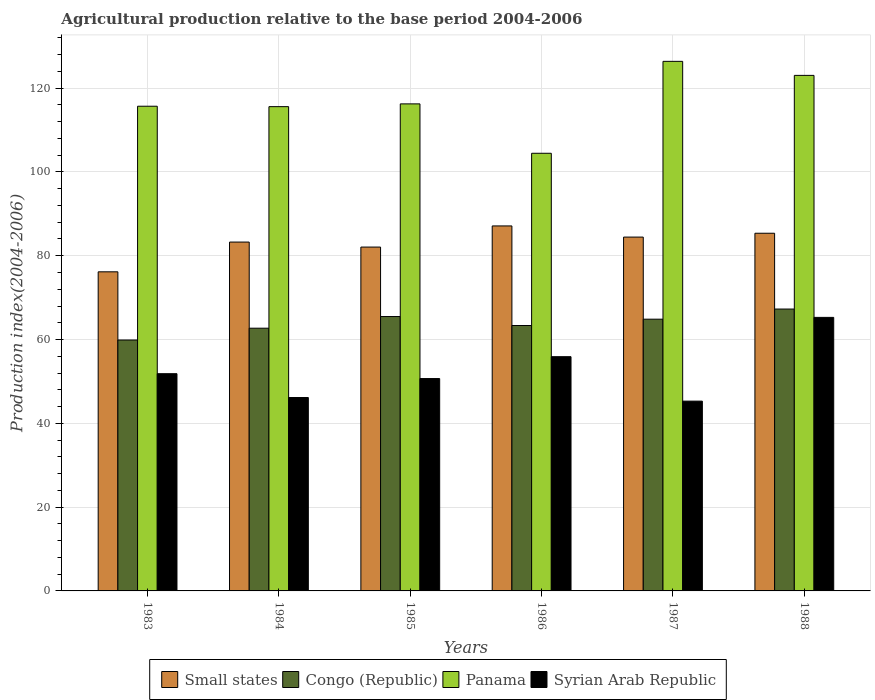How many groups of bars are there?
Ensure brevity in your answer.  6. Are the number of bars per tick equal to the number of legend labels?
Give a very brief answer. Yes. Are the number of bars on each tick of the X-axis equal?
Provide a succinct answer. Yes. How many bars are there on the 6th tick from the left?
Your response must be concise. 4. How many bars are there on the 5th tick from the right?
Offer a terse response. 4. What is the label of the 4th group of bars from the left?
Make the answer very short. 1986. What is the agricultural production index in Syrian Arab Republic in 1983?
Your answer should be compact. 51.85. Across all years, what is the maximum agricultural production index in Syrian Arab Republic?
Your answer should be compact. 65.29. Across all years, what is the minimum agricultural production index in Small states?
Your answer should be very brief. 76.16. In which year was the agricultural production index in Syrian Arab Republic minimum?
Provide a short and direct response. 1987. What is the total agricultural production index in Small states in the graph?
Your answer should be very brief. 498.45. What is the difference between the agricultural production index in Congo (Republic) in 1986 and that in 1987?
Provide a short and direct response. -1.51. What is the difference between the agricultural production index in Panama in 1987 and the agricultural production index in Syrian Arab Republic in 1983?
Offer a terse response. 74.55. What is the average agricultural production index in Congo (Republic) per year?
Provide a short and direct response. 63.93. In the year 1984, what is the difference between the agricultural production index in Small states and agricultural production index in Congo (Republic)?
Your answer should be very brief. 20.56. In how many years, is the agricultural production index in Congo (Republic) greater than 12?
Your answer should be very brief. 6. What is the ratio of the agricultural production index in Syrian Arab Republic in 1983 to that in 1987?
Your answer should be very brief. 1.14. Is the agricultural production index in Small states in 1984 less than that in 1985?
Ensure brevity in your answer.  No. What is the difference between the highest and the second highest agricultural production index in Panama?
Give a very brief answer. 3.35. What is the difference between the highest and the lowest agricultural production index in Small states?
Keep it short and to the point. 10.96. Is it the case that in every year, the sum of the agricultural production index in Syrian Arab Republic and agricultural production index in Congo (Republic) is greater than the sum of agricultural production index in Small states and agricultural production index in Panama?
Ensure brevity in your answer.  No. What does the 2nd bar from the left in 1984 represents?
Give a very brief answer. Congo (Republic). What does the 4th bar from the right in 1984 represents?
Provide a succinct answer. Small states. Is it the case that in every year, the sum of the agricultural production index in Small states and agricultural production index in Panama is greater than the agricultural production index in Syrian Arab Republic?
Your answer should be very brief. Yes. How many bars are there?
Ensure brevity in your answer.  24. Are all the bars in the graph horizontal?
Your response must be concise. No. Are the values on the major ticks of Y-axis written in scientific E-notation?
Give a very brief answer. No. Does the graph contain any zero values?
Give a very brief answer. No. Does the graph contain grids?
Offer a terse response. Yes. Where does the legend appear in the graph?
Give a very brief answer. Bottom center. How are the legend labels stacked?
Your response must be concise. Horizontal. What is the title of the graph?
Provide a short and direct response. Agricultural production relative to the base period 2004-2006. What is the label or title of the Y-axis?
Ensure brevity in your answer.  Production index(2004-2006). What is the Production index(2004-2006) of Small states in 1983?
Keep it short and to the point. 76.16. What is the Production index(2004-2006) of Congo (Republic) in 1983?
Your answer should be compact. 59.89. What is the Production index(2004-2006) in Panama in 1983?
Make the answer very short. 115.69. What is the Production index(2004-2006) of Syrian Arab Republic in 1983?
Your answer should be compact. 51.85. What is the Production index(2004-2006) of Small states in 1984?
Ensure brevity in your answer.  83.27. What is the Production index(2004-2006) in Congo (Republic) in 1984?
Offer a terse response. 62.71. What is the Production index(2004-2006) in Panama in 1984?
Offer a very short reply. 115.59. What is the Production index(2004-2006) of Syrian Arab Republic in 1984?
Your answer should be compact. 46.16. What is the Production index(2004-2006) in Small states in 1985?
Your response must be concise. 82.07. What is the Production index(2004-2006) in Congo (Republic) in 1985?
Offer a very short reply. 65.49. What is the Production index(2004-2006) in Panama in 1985?
Make the answer very short. 116.25. What is the Production index(2004-2006) of Syrian Arab Republic in 1985?
Your answer should be very brief. 50.69. What is the Production index(2004-2006) in Small states in 1986?
Give a very brief answer. 87.12. What is the Production index(2004-2006) of Congo (Republic) in 1986?
Your answer should be compact. 63.35. What is the Production index(2004-2006) of Panama in 1986?
Provide a short and direct response. 104.46. What is the Production index(2004-2006) of Syrian Arab Republic in 1986?
Keep it short and to the point. 55.91. What is the Production index(2004-2006) in Small states in 1987?
Keep it short and to the point. 84.46. What is the Production index(2004-2006) in Congo (Republic) in 1987?
Your answer should be compact. 64.86. What is the Production index(2004-2006) of Panama in 1987?
Your response must be concise. 126.4. What is the Production index(2004-2006) of Syrian Arab Republic in 1987?
Keep it short and to the point. 45.3. What is the Production index(2004-2006) in Small states in 1988?
Give a very brief answer. 85.37. What is the Production index(2004-2006) in Congo (Republic) in 1988?
Provide a short and direct response. 67.28. What is the Production index(2004-2006) of Panama in 1988?
Your answer should be compact. 123.05. What is the Production index(2004-2006) in Syrian Arab Republic in 1988?
Provide a short and direct response. 65.29. Across all years, what is the maximum Production index(2004-2006) in Small states?
Your answer should be compact. 87.12. Across all years, what is the maximum Production index(2004-2006) in Congo (Republic)?
Keep it short and to the point. 67.28. Across all years, what is the maximum Production index(2004-2006) in Panama?
Your answer should be compact. 126.4. Across all years, what is the maximum Production index(2004-2006) in Syrian Arab Republic?
Ensure brevity in your answer.  65.29. Across all years, what is the minimum Production index(2004-2006) of Small states?
Offer a very short reply. 76.16. Across all years, what is the minimum Production index(2004-2006) of Congo (Republic)?
Your answer should be compact. 59.89. Across all years, what is the minimum Production index(2004-2006) of Panama?
Keep it short and to the point. 104.46. Across all years, what is the minimum Production index(2004-2006) in Syrian Arab Republic?
Offer a very short reply. 45.3. What is the total Production index(2004-2006) in Small states in the graph?
Keep it short and to the point. 498.45. What is the total Production index(2004-2006) of Congo (Republic) in the graph?
Ensure brevity in your answer.  383.58. What is the total Production index(2004-2006) in Panama in the graph?
Offer a very short reply. 701.44. What is the total Production index(2004-2006) in Syrian Arab Republic in the graph?
Ensure brevity in your answer.  315.2. What is the difference between the Production index(2004-2006) of Small states in 1983 and that in 1984?
Your answer should be very brief. -7.1. What is the difference between the Production index(2004-2006) of Congo (Republic) in 1983 and that in 1984?
Offer a terse response. -2.82. What is the difference between the Production index(2004-2006) of Panama in 1983 and that in 1984?
Offer a terse response. 0.1. What is the difference between the Production index(2004-2006) in Syrian Arab Republic in 1983 and that in 1984?
Provide a succinct answer. 5.69. What is the difference between the Production index(2004-2006) in Small states in 1983 and that in 1985?
Ensure brevity in your answer.  -5.91. What is the difference between the Production index(2004-2006) in Congo (Republic) in 1983 and that in 1985?
Give a very brief answer. -5.6. What is the difference between the Production index(2004-2006) of Panama in 1983 and that in 1985?
Your response must be concise. -0.56. What is the difference between the Production index(2004-2006) of Syrian Arab Republic in 1983 and that in 1985?
Your answer should be compact. 1.16. What is the difference between the Production index(2004-2006) of Small states in 1983 and that in 1986?
Offer a very short reply. -10.96. What is the difference between the Production index(2004-2006) of Congo (Republic) in 1983 and that in 1986?
Your response must be concise. -3.46. What is the difference between the Production index(2004-2006) of Panama in 1983 and that in 1986?
Offer a very short reply. 11.23. What is the difference between the Production index(2004-2006) in Syrian Arab Republic in 1983 and that in 1986?
Your answer should be compact. -4.06. What is the difference between the Production index(2004-2006) in Small states in 1983 and that in 1987?
Offer a terse response. -8.29. What is the difference between the Production index(2004-2006) in Congo (Republic) in 1983 and that in 1987?
Your answer should be compact. -4.97. What is the difference between the Production index(2004-2006) in Panama in 1983 and that in 1987?
Provide a short and direct response. -10.71. What is the difference between the Production index(2004-2006) of Syrian Arab Republic in 1983 and that in 1987?
Your answer should be compact. 6.55. What is the difference between the Production index(2004-2006) of Small states in 1983 and that in 1988?
Keep it short and to the point. -9.21. What is the difference between the Production index(2004-2006) of Congo (Republic) in 1983 and that in 1988?
Provide a short and direct response. -7.39. What is the difference between the Production index(2004-2006) of Panama in 1983 and that in 1988?
Your answer should be compact. -7.36. What is the difference between the Production index(2004-2006) of Syrian Arab Republic in 1983 and that in 1988?
Your response must be concise. -13.44. What is the difference between the Production index(2004-2006) of Small states in 1984 and that in 1985?
Keep it short and to the point. 1.19. What is the difference between the Production index(2004-2006) in Congo (Republic) in 1984 and that in 1985?
Your answer should be compact. -2.78. What is the difference between the Production index(2004-2006) of Panama in 1984 and that in 1985?
Your response must be concise. -0.66. What is the difference between the Production index(2004-2006) of Syrian Arab Republic in 1984 and that in 1985?
Make the answer very short. -4.53. What is the difference between the Production index(2004-2006) in Small states in 1984 and that in 1986?
Your answer should be compact. -3.85. What is the difference between the Production index(2004-2006) in Congo (Republic) in 1984 and that in 1986?
Provide a short and direct response. -0.64. What is the difference between the Production index(2004-2006) of Panama in 1984 and that in 1986?
Your answer should be compact. 11.13. What is the difference between the Production index(2004-2006) of Syrian Arab Republic in 1984 and that in 1986?
Offer a very short reply. -9.75. What is the difference between the Production index(2004-2006) in Small states in 1984 and that in 1987?
Provide a short and direct response. -1.19. What is the difference between the Production index(2004-2006) of Congo (Republic) in 1984 and that in 1987?
Your response must be concise. -2.15. What is the difference between the Production index(2004-2006) in Panama in 1984 and that in 1987?
Ensure brevity in your answer.  -10.81. What is the difference between the Production index(2004-2006) of Syrian Arab Republic in 1984 and that in 1987?
Ensure brevity in your answer.  0.86. What is the difference between the Production index(2004-2006) of Small states in 1984 and that in 1988?
Offer a terse response. -2.11. What is the difference between the Production index(2004-2006) in Congo (Republic) in 1984 and that in 1988?
Your answer should be compact. -4.57. What is the difference between the Production index(2004-2006) of Panama in 1984 and that in 1988?
Make the answer very short. -7.46. What is the difference between the Production index(2004-2006) of Syrian Arab Republic in 1984 and that in 1988?
Keep it short and to the point. -19.13. What is the difference between the Production index(2004-2006) of Small states in 1985 and that in 1986?
Ensure brevity in your answer.  -5.05. What is the difference between the Production index(2004-2006) in Congo (Republic) in 1985 and that in 1986?
Give a very brief answer. 2.14. What is the difference between the Production index(2004-2006) in Panama in 1985 and that in 1986?
Make the answer very short. 11.79. What is the difference between the Production index(2004-2006) in Syrian Arab Republic in 1985 and that in 1986?
Keep it short and to the point. -5.22. What is the difference between the Production index(2004-2006) of Small states in 1985 and that in 1987?
Make the answer very short. -2.38. What is the difference between the Production index(2004-2006) in Congo (Republic) in 1985 and that in 1987?
Provide a succinct answer. 0.63. What is the difference between the Production index(2004-2006) in Panama in 1985 and that in 1987?
Give a very brief answer. -10.15. What is the difference between the Production index(2004-2006) in Syrian Arab Republic in 1985 and that in 1987?
Ensure brevity in your answer.  5.39. What is the difference between the Production index(2004-2006) of Small states in 1985 and that in 1988?
Your answer should be very brief. -3.3. What is the difference between the Production index(2004-2006) of Congo (Republic) in 1985 and that in 1988?
Make the answer very short. -1.79. What is the difference between the Production index(2004-2006) in Syrian Arab Republic in 1985 and that in 1988?
Your answer should be very brief. -14.6. What is the difference between the Production index(2004-2006) in Small states in 1986 and that in 1987?
Your answer should be very brief. 2.66. What is the difference between the Production index(2004-2006) in Congo (Republic) in 1986 and that in 1987?
Your answer should be very brief. -1.51. What is the difference between the Production index(2004-2006) in Panama in 1986 and that in 1987?
Provide a short and direct response. -21.94. What is the difference between the Production index(2004-2006) in Syrian Arab Republic in 1986 and that in 1987?
Offer a terse response. 10.61. What is the difference between the Production index(2004-2006) in Small states in 1986 and that in 1988?
Keep it short and to the point. 1.75. What is the difference between the Production index(2004-2006) in Congo (Republic) in 1986 and that in 1988?
Keep it short and to the point. -3.93. What is the difference between the Production index(2004-2006) of Panama in 1986 and that in 1988?
Your answer should be very brief. -18.59. What is the difference between the Production index(2004-2006) of Syrian Arab Republic in 1986 and that in 1988?
Offer a very short reply. -9.38. What is the difference between the Production index(2004-2006) of Small states in 1987 and that in 1988?
Your answer should be very brief. -0.92. What is the difference between the Production index(2004-2006) in Congo (Republic) in 1987 and that in 1988?
Your answer should be compact. -2.42. What is the difference between the Production index(2004-2006) in Panama in 1987 and that in 1988?
Provide a succinct answer. 3.35. What is the difference between the Production index(2004-2006) of Syrian Arab Republic in 1987 and that in 1988?
Provide a short and direct response. -19.99. What is the difference between the Production index(2004-2006) in Small states in 1983 and the Production index(2004-2006) in Congo (Republic) in 1984?
Your answer should be compact. 13.45. What is the difference between the Production index(2004-2006) of Small states in 1983 and the Production index(2004-2006) of Panama in 1984?
Give a very brief answer. -39.43. What is the difference between the Production index(2004-2006) of Small states in 1983 and the Production index(2004-2006) of Syrian Arab Republic in 1984?
Your response must be concise. 30. What is the difference between the Production index(2004-2006) in Congo (Republic) in 1983 and the Production index(2004-2006) in Panama in 1984?
Offer a terse response. -55.7. What is the difference between the Production index(2004-2006) of Congo (Republic) in 1983 and the Production index(2004-2006) of Syrian Arab Republic in 1984?
Give a very brief answer. 13.73. What is the difference between the Production index(2004-2006) of Panama in 1983 and the Production index(2004-2006) of Syrian Arab Republic in 1984?
Offer a terse response. 69.53. What is the difference between the Production index(2004-2006) in Small states in 1983 and the Production index(2004-2006) in Congo (Republic) in 1985?
Your answer should be very brief. 10.67. What is the difference between the Production index(2004-2006) in Small states in 1983 and the Production index(2004-2006) in Panama in 1985?
Ensure brevity in your answer.  -40.09. What is the difference between the Production index(2004-2006) in Small states in 1983 and the Production index(2004-2006) in Syrian Arab Republic in 1985?
Provide a short and direct response. 25.47. What is the difference between the Production index(2004-2006) of Congo (Republic) in 1983 and the Production index(2004-2006) of Panama in 1985?
Make the answer very short. -56.36. What is the difference between the Production index(2004-2006) in Panama in 1983 and the Production index(2004-2006) in Syrian Arab Republic in 1985?
Provide a succinct answer. 65. What is the difference between the Production index(2004-2006) in Small states in 1983 and the Production index(2004-2006) in Congo (Republic) in 1986?
Offer a terse response. 12.81. What is the difference between the Production index(2004-2006) of Small states in 1983 and the Production index(2004-2006) of Panama in 1986?
Your response must be concise. -28.3. What is the difference between the Production index(2004-2006) of Small states in 1983 and the Production index(2004-2006) of Syrian Arab Republic in 1986?
Offer a very short reply. 20.25. What is the difference between the Production index(2004-2006) of Congo (Republic) in 1983 and the Production index(2004-2006) of Panama in 1986?
Give a very brief answer. -44.57. What is the difference between the Production index(2004-2006) in Congo (Republic) in 1983 and the Production index(2004-2006) in Syrian Arab Republic in 1986?
Keep it short and to the point. 3.98. What is the difference between the Production index(2004-2006) of Panama in 1983 and the Production index(2004-2006) of Syrian Arab Republic in 1986?
Offer a terse response. 59.78. What is the difference between the Production index(2004-2006) in Small states in 1983 and the Production index(2004-2006) in Congo (Republic) in 1987?
Your response must be concise. 11.3. What is the difference between the Production index(2004-2006) in Small states in 1983 and the Production index(2004-2006) in Panama in 1987?
Keep it short and to the point. -50.24. What is the difference between the Production index(2004-2006) of Small states in 1983 and the Production index(2004-2006) of Syrian Arab Republic in 1987?
Give a very brief answer. 30.86. What is the difference between the Production index(2004-2006) in Congo (Republic) in 1983 and the Production index(2004-2006) in Panama in 1987?
Make the answer very short. -66.51. What is the difference between the Production index(2004-2006) in Congo (Republic) in 1983 and the Production index(2004-2006) in Syrian Arab Republic in 1987?
Provide a short and direct response. 14.59. What is the difference between the Production index(2004-2006) in Panama in 1983 and the Production index(2004-2006) in Syrian Arab Republic in 1987?
Provide a short and direct response. 70.39. What is the difference between the Production index(2004-2006) in Small states in 1983 and the Production index(2004-2006) in Congo (Republic) in 1988?
Provide a succinct answer. 8.88. What is the difference between the Production index(2004-2006) in Small states in 1983 and the Production index(2004-2006) in Panama in 1988?
Keep it short and to the point. -46.89. What is the difference between the Production index(2004-2006) in Small states in 1983 and the Production index(2004-2006) in Syrian Arab Republic in 1988?
Offer a terse response. 10.87. What is the difference between the Production index(2004-2006) in Congo (Republic) in 1983 and the Production index(2004-2006) in Panama in 1988?
Provide a succinct answer. -63.16. What is the difference between the Production index(2004-2006) of Panama in 1983 and the Production index(2004-2006) of Syrian Arab Republic in 1988?
Give a very brief answer. 50.4. What is the difference between the Production index(2004-2006) in Small states in 1984 and the Production index(2004-2006) in Congo (Republic) in 1985?
Give a very brief answer. 17.78. What is the difference between the Production index(2004-2006) of Small states in 1984 and the Production index(2004-2006) of Panama in 1985?
Your answer should be compact. -32.98. What is the difference between the Production index(2004-2006) of Small states in 1984 and the Production index(2004-2006) of Syrian Arab Republic in 1985?
Give a very brief answer. 32.58. What is the difference between the Production index(2004-2006) of Congo (Republic) in 1984 and the Production index(2004-2006) of Panama in 1985?
Give a very brief answer. -53.54. What is the difference between the Production index(2004-2006) in Congo (Republic) in 1984 and the Production index(2004-2006) in Syrian Arab Republic in 1985?
Keep it short and to the point. 12.02. What is the difference between the Production index(2004-2006) of Panama in 1984 and the Production index(2004-2006) of Syrian Arab Republic in 1985?
Your answer should be very brief. 64.9. What is the difference between the Production index(2004-2006) in Small states in 1984 and the Production index(2004-2006) in Congo (Republic) in 1986?
Your answer should be very brief. 19.92. What is the difference between the Production index(2004-2006) of Small states in 1984 and the Production index(2004-2006) of Panama in 1986?
Give a very brief answer. -21.19. What is the difference between the Production index(2004-2006) in Small states in 1984 and the Production index(2004-2006) in Syrian Arab Republic in 1986?
Provide a short and direct response. 27.36. What is the difference between the Production index(2004-2006) in Congo (Republic) in 1984 and the Production index(2004-2006) in Panama in 1986?
Your answer should be very brief. -41.75. What is the difference between the Production index(2004-2006) of Panama in 1984 and the Production index(2004-2006) of Syrian Arab Republic in 1986?
Give a very brief answer. 59.68. What is the difference between the Production index(2004-2006) in Small states in 1984 and the Production index(2004-2006) in Congo (Republic) in 1987?
Your answer should be compact. 18.41. What is the difference between the Production index(2004-2006) in Small states in 1984 and the Production index(2004-2006) in Panama in 1987?
Your answer should be very brief. -43.13. What is the difference between the Production index(2004-2006) of Small states in 1984 and the Production index(2004-2006) of Syrian Arab Republic in 1987?
Your answer should be very brief. 37.97. What is the difference between the Production index(2004-2006) in Congo (Republic) in 1984 and the Production index(2004-2006) in Panama in 1987?
Your answer should be compact. -63.69. What is the difference between the Production index(2004-2006) of Congo (Republic) in 1984 and the Production index(2004-2006) of Syrian Arab Republic in 1987?
Provide a short and direct response. 17.41. What is the difference between the Production index(2004-2006) in Panama in 1984 and the Production index(2004-2006) in Syrian Arab Republic in 1987?
Provide a succinct answer. 70.29. What is the difference between the Production index(2004-2006) of Small states in 1984 and the Production index(2004-2006) of Congo (Republic) in 1988?
Your answer should be compact. 15.99. What is the difference between the Production index(2004-2006) in Small states in 1984 and the Production index(2004-2006) in Panama in 1988?
Make the answer very short. -39.78. What is the difference between the Production index(2004-2006) of Small states in 1984 and the Production index(2004-2006) of Syrian Arab Republic in 1988?
Ensure brevity in your answer.  17.98. What is the difference between the Production index(2004-2006) in Congo (Republic) in 1984 and the Production index(2004-2006) in Panama in 1988?
Your answer should be very brief. -60.34. What is the difference between the Production index(2004-2006) of Congo (Republic) in 1984 and the Production index(2004-2006) of Syrian Arab Republic in 1988?
Offer a very short reply. -2.58. What is the difference between the Production index(2004-2006) in Panama in 1984 and the Production index(2004-2006) in Syrian Arab Republic in 1988?
Ensure brevity in your answer.  50.3. What is the difference between the Production index(2004-2006) of Small states in 1985 and the Production index(2004-2006) of Congo (Republic) in 1986?
Offer a very short reply. 18.72. What is the difference between the Production index(2004-2006) of Small states in 1985 and the Production index(2004-2006) of Panama in 1986?
Give a very brief answer. -22.39. What is the difference between the Production index(2004-2006) in Small states in 1985 and the Production index(2004-2006) in Syrian Arab Republic in 1986?
Keep it short and to the point. 26.16. What is the difference between the Production index(2004-2006) in Congo (Republic) in 1985 and the Production index(2004-2006) in Panama in 1986?
Provide a short and direct response. -38.97. What is the difference between the Production index(2004-2006) of Congo (Republic) in 1985 and the Production index(2004-2006) of Syrian Arab Republic in 1986?
Offer a terse response. 9.58. What is the difference between the Production index(2004-2006) in Panama in 1985 and the Production index(2004-2006) in Syrian Arab Republic in 1986?
Give a very brief answer. 60.34. What is the difference between the Production index(2004-2006) in Small states in 1985 and the Production index(2004-2006) in Congo (Republic) in 1987?
Provide a succinct answer. 17.21. What is the difference between the Production index(2004-2006) in Small states in 1985 and the Production index(2004-2006) in Panama in 1987?
Give a very brief answer. -44.33. What is the difference between the Production index(2004-2006) of Small states in 1985 and the Production index(2004-2006) of Syrian Arab Republic in 1987?
Offer a very short reply. 36.77. What is the difference between the Production index(2004-2006) in Congo (Republic) in 1985 and the Production index(2004-2006) in Panama in 1987?
Offer a terse response. -60.91. What is the difference between the Production index(2004-2006) of Congo (Republic) in 1985 and the Production index(2004-2006) of Syrian Arab Republic in 1987?
Ensure brevity in your answer.  20.19. What is the difference between the Production index(2004-2006) of Panama in 1985 and the Production index(2004-2006) of Syrian Arab Republic in 1987?
Your response must be concise. 70.95. What is the difference between the Production index(2004-2006) in Small states in 1985 and the Production index(2004-2006) in Congo (Republic) in 1988?
Provide a succinct answer. 14.79. What is the difference between the Production index(2004-2006) of Small states in 1985 and the Production index(2004-2006) of Panama in 1988?
Make the answer very short. -40.98. What is the difference between the Production index(2004-2006) in Small states in 1985 and the Production index(2004-2006) in Syrian Arab Republic in 1988?
Give a very brief answer. 16.78. What is the difference between the Production index(2004-2006) in Congo (Republic) in 1985 and the Production index(2004-2006) in Panama in 1988?
Offer a very short reply. -57.56. What is the difference between the Production index(2004-2006) in Panama in 1985 and the Production index(2004-2006) in Syrian Arab Republic in 1988?
Provide a short and direct response. 50.96. What is the difference between the Production index(2004-2006) of Small states in 1986 and the Production index(2004-2006) of Congo (Republic) in 1987?
Keep it short and to the point. 22.26. What is the difference between the Production index(2004-2006) in Small states in 1986 and the Production index(2004-2006) in Panama in 1987?
Offer a very short reply. -39.28. What is the difference between the Production index(2004-2006) in Small states in 1986 and the Production index(2004-2006) in Syrian Arab Republic in 1987?
Your response must be concise. 41.82. What is the difference between the Production index(2004-2006) of Congo (Republic) in 1986 and the Production index(2004-2006) of Panama in 1987?
Your response must be concise. -63.05. What is the difference between the Production index(2004-2006) in Congo (Republic) in 1986 and the Production index(2004-2006) in Syrian Arab Republic in 1987?
Offer a terse response. 18.05. What is the difference between the Production index(2004-2006) in Panama in 1986 and the Production index(2004-2006) in Syrian Arab Republic in 1987?
Keep it short and to the point. 59.16. What is the difference between the Production index(2004-2006) of Small states in 1986 and the Production index(2004-2006) of Congo (Republic) in 1988?
Keep it short and to the point. 19.84. What is the difference between the Production index(2004-2006) of Small states in 1986 and the Production index(2004-2006) of Panama in 1988?
Provide a succinct answer. -35.93. What is the difference between the Production index(2004-2006) of Small states in 1986 and the Production index(2004-2006) of Syrian Arab Republic in 1988?
Ensure brevity in your answer.  21.83. What is the difference between the Production index(2004-2006) of Congo (Republic) in 1986 and the Production index(2004-2006) of Panama in 1988?
Make the answer very short. -59.7. What is the difference between the Production index(2004-2006) in Congo (Republic) in 1986 and the Production index(2004-2006) in Syrian Arab Republic in 1988?
Provide a succinct answer. -1.94. What is the difference between the Production index(2004-2006) in Panama in 1986 and the Production index(2004-2006) in Syrian Arab Republic in 1988?
Make the answer very short. 39.17. What is the difference between the Production index(2004-2006) in Small states in 1987 and the Production index(2004-2006) in Congo (Republic) in 1988?
Your answer should be compact. 17.18. What is the difference between the Production index(2004-2006) in Small states in 1987 and the Production index(2004-2006) in Panama in 1988?
Your answer should be very brief. -38.59. What is the difference between the Production index(2004-2006) in Small states in 1987 and the Production index(2004-2006) in Syrian Arab Republic in 1988?
Offer a terse response. 19.17. What is the difference between the Production index(2004-2006) in Congo (Republic) in 1987 and the Production index(2004-2006) in Panama in 1988?
Your response must be concise. -58.19. What is the difference between the Production index(2004-2006) of Congo (Republic) in 1987 and the Production index(2004-2006) of Syrian Arab Republic in 1988?
Ensure brevity in your answer.  -0.43. What is the difference between the Production index(2004-2006) in Panama in 1987 and the Production index(2004-2006) in Syrian Arab Republic in 1988?
Your response must be concise. 61.11. What is the average Production index(2004-2006) in Small states per year?
Your response must be concise. 83.08. What is the average Production index(2004-2006) in Congo (Republic) per year?
Give a very brief answer. 63.93. What is the average Production index(2004-2006) of Panama per year?
Provide a short and direct response. 116.91. What is the average Production index(2004-2006) of Syrian Arab Republic per year?
Your answer should be very brief. 52.53. In the year 1983, what is the difference between the Production index(2004-2006) in Small states and Production index(2004-2006) in Congo (Republic)?
Give a very brief answer. 16.27. In the year 1983, what is the difference between the Production index(2004-2006) of Small states and Production index(2004-2006) of Panama?
Your answer should be very brief. -39.53. In the year 1983, what is the difference between the Production index(2004-2006) in Small states and Production index(2004-2006) in Syrian Arab Republic?
Provide a succinct answer. 24.31. In the year 1983, what is the difference between the Production index(2004-2006) of Congo (Republic) and Production index(2004-2006) of Panama?
Your answer should be very brief. -55.8. In the year 1983, what is the difference between the Production index(2004-2006) in Congo (Republic) and Production index(2004-2006) in Syrian Arab Republic?
Keep it short and to the point. 8.04. In the year 1983, what is the difference between the Production index(2004-2006) in Panama and Production index(2004-2006) in Syrian Arab Republic?
Your answer should be very brief. 63.84. In the year 1984, what is the difference between the Production index(2004-2006) in Small states and Production index(2004-2006) in Congo (Republic)?
Keep it short and to the point. 20.56. In the year 1984, what is the difference between the Production index(2004-2006) in Small states and Production index(2004-2006) in Panama?
Your response must be concise. -32.32. In the year 1984, what is the difference between the Production index(2004-2006) of Small states and Production index(2004-2006) of Syrian Arab Republic?
Provide a short and direct response. 37.11. In the year 1984, what is the difference between the Production index(2004-2006) of Congo (Republic) and Production index(2004-2006) of Panama?
Offer a very short reply. -52.88. In the year 1984, what is the difference between the Production index(2004-2006) in Congo (Republic) and Production index(2004-2006) in Syrian Arab Republic?
Offer a terse response. 16.55. In the year 1984, what is the difference between the Production index(2004-2006) of Panama and Production index(2004-2006) of Syrian Arab Republic?
Make the answer very short. 69.43. In the year 1985, what is the difference between the Production index(2004-2006) of Small states and Production index(2004-2006) of Congo (Republic)?
Provide a succinct answer. 16.58. In the year 1985, what is the difference between the Production index(2004-2006) in Small states and Production index(2004-2006) in Panama?
Offer a very short reply. -34.18. In the year 1985, what is the difference between the Production index(2004-2006) in Small states and Production index(2004-2006) in Syrian Arab Republic?
Offer a very short reply. 31.38. In the year 1985, what is the difference between the Production index(2004-2006) in Congo (Republic) and Production index(2004-2006) in Panama?
Provide a short and direct response. -50.76. In the year 1985, what is the difference between the Production index(2004-2006) in Congo (Republic) and Production index(2004-2006) in Syrian Arab Republic?
Keep it short and to the point. 14.8. In the year 1985, what is the difference between the Production index(2004-2006) in Panama and Production index(2004-2006) in Syrian Arab Republic?
Give a very brief answer. 65.56. In the year 1986, what is the difference between the Production index(2004-2006) of Small states and Production index(2004-2006) of Congo (Republic)?
Ensure brevity in your answer.  23.77. In the year 1986, what is the difference between the Production index(2004-2006) in Small states and Production index(2004-2006) in Panama?
Your response must be concise. -17.34. In the year 1986, what is the difference between the Production index(2004-2006) in Small states and Production index(2004-2006) in Syrian Arab Republic?
Offer a terse response. 31.21. In the year 1986, what is the difference between the Production index(2004-2006) in Congo (Republic) and Production index(2004-2006) in Panama?
Provide a succinct answer. -41.11. In the year 1986, what is the difference between the Production index(2004-2006) in Congo (Republic) and Production index(2004-2006) in Syrian Arab Republic?
Your response must be concise. 7.44. In the year 1986, what is the difference between the Production index(2004-2006) of Panama and Production index(2004-2006) of Syrian Arab Republic?
Your response must be concise. 48.55. In the year 1987, what is the difference between the Production index(2004-2006) of Small states and Production index(2004-2006) of Congo (Republic)?
Give a very brief answer. 19.6. In the year 1987, what is the difference between the Production index(2004-2006) of Small states and Production index(2004-2006) of Panama?
Give a very brief answer. -41.94. In the year 1987, what is the difference between the Production index(2004-2006) in Small states and Production index(2004-2006) in Syrian Arab Republic?
Offer a terse response. 39.16. In the year 1987, what is the difference between the Production index(2004-2006) of Congo (Republic) and Production index(2004-2006) of Panama?
Offer a terse response. -61.54. In the year 1987, what is the difference between the Production index(2004-2006) of Congo (Republic) and Production index(2004-2006) of Syrian Arab Republic?
Give a very brief answer. 19.56. In the year 1987, what is the difference between the Production index(2004-2006) in Panama and Production index(2004-2006) in Syrian Arab Republic?
Your answer should be very brief. 81.1. In the year 1988, what is the difference between the Production index(2004-2006) of Small states and Production index(2004-2006) of Congo (Republic)?
Offer a very short reply. 18.09. In the year 1988, what is the difference between the Production index(2004-2006) in Small states and Production index(2004-2006) in Panama?
Offer a terse response. -37.68. In the year 1988, what is the difference between the Production index(2004-2006) of Small states and Production index(2004-2006) of Syrian Arab Republic?
Keep it short and to the point. 20.08. In the year 1988, what is the difference between the Production index(2004-2006) in Congo (Republic) and Production index(2004-2006) in Panama?
Offer a very short reply. -55.77. In the year 1988, what is the difference between the Production index(2004-2006) in Congo (Republic) and Production index(2004-2006) in Syrian Arab Republic?
Your answer should be compact. 1.99. In the year 1988, what is the difference between the Production index(2004-2006) of Panama and Production index(2004-2006) of Syrian Arab Republic?
Your answer should be compact. 57.76. What is the ratio of the Production index(2004-2006) in Small states in 1983 to that in 1984?
Make the answer very short. 0.91. What is the ratio of the Production index(2004-2006) of Congo (Republic) in 1983 to that in 1984?
Keep it short and to the point. 0.95. What is the ratio of the Production index(2004-2006) of Syrian Arab Republic in 1983 to that in 1984?
Ensure brevity in your answer.  1.12. What is the ratio of the Production index(2004-2006) in Small states in 1983 to that in 1985?
Give a very brief answer. 0.93. What is the ratio of the Production index(2004-2006) of Congo (Republic) in 1983 to that in 1985?
Give a very brief answer. 0.91. What is the ratio of the Production index(2004-2006) of Panama in 1983 to that in 1985?
Ensure brevity in your answer.  1. What is the ratio of the Production index(2004-2006) of Syrian Arab Republic in 1983 to that in 1985?
Provide a short and direct response. 1.02. What is the ratio of the Production index(2004-2006) of Small states in 1983 to that in 1986?
Your response must be concise. 0.87. What is the ratio of the Production index(2004-2006) in Congo (Republic) in 1983 to that in 1986?
Your response must be concise. 0.95. What is the ratio of the Production index(2004-2006) of Panama in 1983 to that in 1986?
Your answer should be compact. 1.11. What is the ratio of the Production index(2004-2006) of Syrian Arab Republic in 1983 to that in 1986?
Your answer should be very brief. 0.93. What is the ratio of the Production index(2004-2006) in Small states in 1983 to that in 1987?
Your answer should be very brief. 0.9. What is the ratio of the Production index(2004-2006) of Congo (Republic) in 1983 to that in 1987?
Give a very brief answer. 0.92. What is the ratio of the Production index(2004-2006) in Panama in 1983 to that in 1987?
Make the answer very short. 0.92. What is the ratio of the Production index(2004-2006) in Syrian Arab Republic in 1983 to that in 1987?
Make the answer very short. 1.14. What is the ratio of the Production index(2004-2006) of Small states in 1983 to that in 1988?
Offer a very short reply. 0.89. What is the ratio of the Production index(2004-2006) of Congo (Republic) in 1983 to that in 1988?
Offer a terse response. 0.89. What is the ratio of the Production index(2004-2006) in Panama in 1983 to that in 1988?
Your answer should be compact. 0.94. What is the ratio of the Production index(2004-2006) of Syrian Arab Republic in 1983 to that in 1988?
Give a very brief answer. 0.79. What is the ratio of the Production index(2004-2006) of Small states in 1984 to that in 1985?
Your response must be concise. 1.01. What is the ratio of the Production index(2004-2006) in Congo (Republic) in 1984 to that in 1985?
Your response must be concise. 0.96. What is the ratio of the Production index(2004-2006) in Panama in 1984 to that in 1985?
Your answer should be compact. 0.99. What is the ratio of the Production index(2004-2006) in Syrian Arab Republic in 1984 to that in 1985?
Give a very brief answer. 0.91. What is the ratio of the Production index(2004-2006) in Small states in 1984 to that in 1986?
Provide a short and direct response. 0.96. What is the ratio of the Production index(2004-2006) in Congo (Republic) in 1984 to that in 1986?
Make the answer very short. 0.99. What is the ratio of the Production index(2004-2006) of Panama in 1984 to that in 1986?
Provide a short and direct response. 1.11. What is the ratio of the Production index(2004-2006) of Syrian Arab Republic in 1984 to that in 1986?
Give a very brief answer. 0.83. What is the ratio of the Production index(2004-2006) in Small states in 1984 to that in 1987?
Provide a succinct answer. 0.99. What is the ratio of the Production index(2004-2006) in Congo (Republic) in 1984 to that in 1987?
Ensure brevity in your answer.  0.97. What is the ratio of the Production index(2004-2006) of Panama in 1984 to that in 1987?
Your answer should be compact. 0.91. What is the ratio of the Production index(2004-2006) of Syrian Arab Republic in 1984 to that in 1987?
Your answer should be compact. 1.02. What is the ratio of the Production index(2004-2006) of Small states in 1984 to that in 1988?
Give a very brief answer. 0.98. What is the ratio of the Production index(2004-2006) of Congo (Republic) in 1984 to that in 1988?
Your answer should be very brief. 0.93. What is the ratio of the Production index(2004-2006) of Panama in 1984 to that in 1988?
Provide a succinct answer. 0.94. What is the ratio of the Production index(2004-2006) of Syrian Arab Republic in 1984 to that in 1988?
Give a very brief answer. 0.71. What is the ratio of the Production index(2004-2006) in Small states in 1985 to that in 1986?
Provide a short and direct response. 0.94. What is the ratio of the Production index(2004-2006) in Congo (Republic) in 1985 to that in 1986?
Provide a succinct answer. 1.03. What is the ratio of the Production index(2004-2006) in Panama in 1985 to that in 1986?
Your answer should be very brief. 1.11. What is the ratio of the Production index(2004-2006) of Syrian Arab Republic in 1985 to that in 1986?
Ensure brevity in your answer.  0.91. What is the ratio of the Production index(2004-2006) in Small states in 1985 to that in 1987?
Your answer should be compact. 0.97. What is the ratio of the Production index(2004-2006) of Congo (Republic) in 1985 to that in 1987?
Give a very brief answer. 1.01. What is the ratio of the Production index(2004-2006) of Panama in 1985 to that in 1987?
Ensure brevity in your answer.  0.92. What is the ratio of the Production index(2004-2006) of Syrian Arab Republic in 1985 to that in 1987?
Offer a very short reply. 1.12. What is the ratio of the Production index(2004-2006) in Small states in 1985 to that in 1988?
Ensure brevity in your answer.  0.96. What is the ratio of the Production index(2004-2006) of Congo (Republic) in 1985 to that in 1988?
Your response must be concise. 0.97. What is the ratio of the Production index(2004-2006) of Panama in 1985 to that in 1988?
Your response must be concise. 0.94. What is the ratio of the Production index(2004-2006) in Syrian Arab Republic in 1985 to that in 1988?
Provide a succinct answer. 0.78. What is the ratio of the Production index(2004-2006) of Small states in 1986 to that in 1987?
Make the answer very short. 1.03. What is the ratio of the Production index(2004-2006) in Congo (Republic) in 1986 to that in 1987?
Make the answer very short. 0.98. What is the ratio of the Production index(2004-2006) in Panama in 1986 to that in 1987?
Provide a short and direct response. 0.83. What is the ratio of the Production index(2004-2006) in Syrian Arab Republic in 1986 to that in 1987?
Keep it short and to the point. 1.23. What is the ratio of the Production index(2004-2006) in Small states in 1986 to that in 1988?
Keep it short and to the point. 1.02. What is the ratio of the Production index(2004-2006) of Congo (Republic) in 1986 to that in 1988?
Provide a succinct answer. 0.94. What is the ratio of the Production index(2004-2006) in Panama in 1986 to that in 1988?
Your response must be concise. 0.85. What is the ratio of the Production index(2004-2006) of Syrian Arab Republic in 1986 to that in 1988?
Ensure brevity in your answer.  0.86. What is the ratio of the Production index(2004-2006) of Small states in 1987 to that in 1988?
Provide a short and direct response. 0.99. What is the ratio of the Production index(2004-2006) of Congo (Republic) in 1987 to that in 1988?
Your answer should be compact. 0.96. What is the ratio of the Production index(2004-2006) in Panama in 1987 to that in 1988?
Keep it short and to the point. 1.03. What is the ratio of the Production index(2004-2006) of Syrian Arab Republic in 1987 to that in 1988?
Offer a very short reply. 0.69. What is the difference between the highest and the second highest Production index(2004-2006) of Small states?
Your answer should be compact. 1.75. What is the difference between the highest and the second highest Production index(2004-2006) in Congo (Republic)?
Offer a terse response. 1.79. What is the difference between the highest and the second highest Production index(2004-2006) in Panama?
Ensure brevity in your answer.  3.35. What is the difference between the highest and the second highest Production index(2004-2006) of Syrian Arab Republic?
Offer a very short reply. 9.38. What is the difference between the highest and the lowest Production index(2004-2006) of Small states?
Keep it short and to the point. 10.96. What is the difference between the highest and the lowest Production index(2004-2006) of Congo (Republic)?
Your answer should be compact. 7.39. What is the difference between the highest and the lowest Production index(2004-2006) in Panama?
Your response must be concise. 21.94. What is the difference between the highest and the lowest Production index(2004-2006) in Syrian Arab Republic?
Provide a succinct answer. 19.99. 